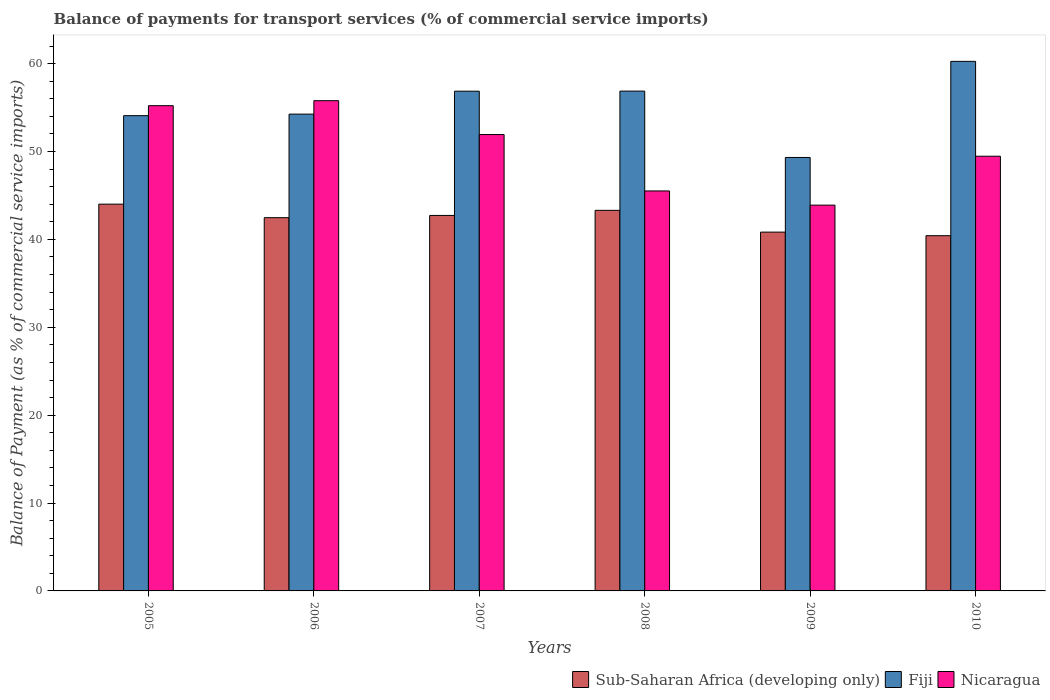Are the number of bars per tick equal to the number of legend labels?
Provide a succinct answer. Yes. Are the number of bars on each tick of the X-axis equal?
Ensure brevity in your answer.  Yes. How many bars are there on the 4th tick from the left?
Your answer should be compact. 3. What is the balance of payments for transport services in Nicaragua in 2009?
Keep it short and to the point. 43.9. Across all years, what is the maximum balance of payments for transport services in Nicaragua?
Offer a terse response. 55.78. Across all years, what is the minimum balance of payments for transport services in Sub-Saharan Africa (developing only)?
Your answer should be compact. 40.42. In which year was the balance of payments for transport services in Fiji maximum?
Offer a very short reply. 2010. What is the total balance of payments for transport services in Nicaragua in the graph?
Provide a short and direct response. 301.81. What is the difference between the balance of payments for transport services in Nicaragua in 2005 and that in 2009?
Provide a short and direct response. 11.32. What is the difference between the balance of payments for transport services in Nicaragua in 2007 and the balance of payments for transport services in Sub-Saharan Africa (developing only) in 2010?
Your answer should be very brief. 11.51. What is the average balance of payments for transport services in Nicaragua per year?
Your answer should be compact. 50.3. In the year 2008, what is the difference between the balance of payments for transport services in Nicaragua and balance of payments for transport services in Fiji?
Make the answer very short. -11.36. In how many years, is the balance of payments for transport services in Nicaragua greater than 32 %?
Give a very brief answer. 6. What is the ratio of the balance of payments for transport services in Sub-Saharan Africa (developing only) in 2007 to that in 2009?
Your response must be concise. 1.05. Is the difference between the balance of payments for transport services in Nicaragua in 2007 and 2008 greater than the difference between the balance of payments for transport services in Fiji in 2007 and 2008?
Give a very brief answer. Yes. What is the difference between the highest and the second highest balance of payments for transport services in Sub-Saharan Africa (developing only)?
Provide a short and direct response. 0.7. What is the difference between the highest and the lowest balance of payments for transport services in Fiji?
Give a very brief answer. 10.94. In how many years, is the balance of payments for transport services in Nicaragua greater than the average balance of payments for transport services in Nicaragua taken over all years?
Your answer should be compact. 3. What does the 1st bar from the left in 2005 represents?
Offer a very short reply. Sub-Saharan Africa (developing only). What does the 3rd bar from the right in 2009 represents?
Make the answer very short. Sub-Saharan Africa (developing only). Is it the case that in every year, the sum of the balance of payments for transport services in Sub-Saharan Africa (developing only) and balance of payments for transport services in Fiji is greater than the balance of payments for transport services in Nicaragua?
Provide a short and direct response. Yes. Are all the bars in the graph horizontal?
Your answer should be very brief. No. Are the values on the major ticks of Y-axis written in scientific E-notation?
Your answer should be compact. No. What is the title of the graph?
Give a very brief answer. Balance of payments for transport services (% of commercial service imports). Does "St. Vincent and the Grenadines" appear as one of the legend labels in the graph?
Your answer should be very brief. No. What is the label or title of the Y-axis?
Offer a very short reply. Balance of Payment (as % of commercial service imports). What is the Balance of Payment (as % of commercial service imports) in Sub-Saharan Africa (developing only) in 2005?
Provide a succinct answer. 44.01. What is the Balance of Payment (as % of commercial service imports) of Fiji in 2005?
Offer a very short reply. 54.08. What is the Balance of Payment (as % of commercial service imports) of Nicaragua in 2005?
Ensure brevity in your answer.  55.22. What is the Balance of Payment (as % of commercial service imports) of Sub-Saharan Africa (developing only) in 2006?
Make the answer very short. 42.47. What is the Balance of Payment (as % of commercial service imports) in Fiji in 2006?
Make the answer very short. 54.25. What is the Balance of Payment (as % of commercial service imports) in Nicaragua in 2006?
Your answer should be very brief. 55.78. What is the Balance of Payment (as % of commercial service imports) in Sub-Saharan Africa (developing only) in 2007?
Keep it short and to the point. 42.73. What is the Balance of Payment (as % of commercial service imports) in Fiji in 2007?
Make the answer very short. 56.86. What is the Balance of Payment (as % of commercial service imports) of Nicaragua in 2007?
Make the answer very short. 51.93. What is the Balance of Payment (as % of commercial service imports) of Sub-Saharan Africa (developing only) in 2008?
Ensure brevity in your answer.  43.31. What is the Balance of Payment (as % of commercial service imports) of Fiji in 2008?
Give a very brief answer. 56.87. What is the Balance of Payment (as % of commercial service imports) of Nicaragua in 2008?
Give a very brief answer. 45.51. What is the Balance of Payment (as % of commercial service imports) of Sub-Saharan Africa (developing only) in 2009?
Ensure brevity in your answer.  40.83. What is the Balance of Payment (as % of commercial service imports) of Fiji in 2009?
Give a very brief answer. 49.32. What is the Balance of Payment (as % of commercial service imports) of Nicaragua in 2009?
Provide a short and direct response. 43.9. What is the Balance of Payment (as % of commercial service imports) of Sub-Saharan Africa (developing only) in 2010?
Your answer should be very brief. 40.42. What is the Balance of Payment (as % of commercial service imports) in Fiji in 2010?
Provide a succinct answer. 60.26. What is the Balance of Payment (as % of commercial service imports) in Nicaragua in 2010?
Make the answer very short. 49.46. Across all years, what is the maximum Balance of Payment (as % of commercial service imports) in Sub-Saharan Africa (developing only)?
Offer a terse response. 44.01. Across all years, what is the maximum Balance of Payment (as % of commercial service imports) of Fiji?
Provide a succinct answer. 60.26. Across all years, what is the maximum Balance of Payment (as % of commercial service imports) of Nicaragua?
Ensure brevity in your answer.  55.78. Across all years, what is the minimum Balance of Payment (as % of commercial service imports) of Sub-Saharan Africa (developing only)?
Your response must be concise. 40.42. Across all years, what is the minimum Balance of Payment (as % of commercial service imports) in Fiji?
Your answer should be very brief. 49.32. Across all years, what is the minimum Balance of Payment (as % of commercial service imports) of Nicaragua?
Keep it short and to the point. 43.9. What is the total Balance of Payment (as % of commercial service imports) in Sub-Saharan Africa (developing only) in the graph?
Offer a terse response. 253.76. What is the total Balance of Payment (as % of commercial service imports) of Fiji in the graph?
Provide a short and direct response. 331.65. What is the total Balance of Payment (as % of commercial service imports) of Nicaragua in the graph?
Keep it short and to the point. 301.81. What is the difference between the Balance of Payment (as % of commercial service imports) in Sub-Saharan Africa (developing only) in 2005 and that in 2006?
Provide a succinct answer. 1.54. What is the difference between the Balance of Payment (as % of commercial service imports) in Fiji in 2005 and that in 2006?
Your answer should be very brief. -0.18. What is the difference between the Balance of Payment (as % of commercial service imports) of Nicaragua in 2005 and that in 2006?
Your answer should be compact. -0.57. What is the difference between the Balance of Payment (as % of commercial service imports) of Sub-Saharan Africa (developing only) in 2005 and that in 2007?
Offer a terse response. 1.28. What is the difference between the Balance of Payment (as % of commercial service imports) of Fiji in 2005 and that in 2007?
Provide a short and direct response. -2.78. What is the difference between the Balance of Payment (as % of commercial service imports) in Nicaragua in 2005 and that in 2007?
Offer a terse response. 3.29. What is the difference between the Balance of Payment (as % of commercial service imports) in Sub-Saharan Africa (developing only) in 2005 and that in 2008?
Provide a succinct answer. 0.7. What is the difference between the Balance of Payment (as % of commercial service imports) in Fiji in 2005 and that in 2008?
Provide a short and direct response. -2.8. What is the difference between the Balance of Payment (as % of commercial service imports) of Nicaragua in 2005 and that in 2008?
Make the answer very short. 9.7. What is the difference between the Balance of Payment (as % of commercial service imports) of Sub-Saharan Africa (developing only) in 2005 and that in 2009?
Keep it short and to the point. 3.18. What is the difference between the Balance of Payment (as % of commercial service imports) in Fiji in 2005 and that in 2009?
Make the answer very short. 4.76. What is the difference between the Balance of Payment (as % of commercial service imports) of Nicaragua in 2005 and that in 2009?
Your answer should be compact. 11.32. What is the difference between the Balance of Payment (as % of commercial service imports) in Sub-Saharan Africa (developing only) in 2005 and that in 2010?
Provide a succinct answer. 3.59. What is the difference between the Balance of Payment (as % of commercial service imports) in Fiji in 2005 and that in 2010?
Keep it short and to the point. -6.18. What is the difference between the Balance of Payment (as % of commercial service imports) in Nicaragua in 2005 and that in 2010?
Your answer should be compact. 5.75. What is the difference between the Balance of Payment (as % of commercial service imports) of Sub-Saharan Africa (developing only) in 2006 and that in 2007?
Offer a terse response. -0.26. What is the difference between the Balance of Payment (as % of commercial service imports) in Fiji in 2006 and that in 2007?
Your response must be concise. -2.61. What is the difference between the Balance of Payment (as % of commercial service imports) in Nicaragua in 2006 and that in 2007?
Make the answer very short. 3.85. What is the difference between the Balance of Payment (as % of commercial service imports) in Sub-Saharan Africa (developing only) in 2006 and that in 2008?
Make the answer very short. -0.84. What is the difference between the Balance of Payment (as % of commercial service imports) of Fiji in 2006 and that in 2008?
Keep it short and to the point. -2.62. What is the difference between the Balance of Payment (as % of commercial service imports) in Nicaragua in 2006 and that in 2008?
Provide a short and direct response. 10.27. What is the difference between the Balance of Payment (as % of commercial service imports) of Sub-Saharan Africa (developing only) in 2006 and that in 2009?
Your response must be concise. 1.64. What is the difference between the Balance of Payment (as % of commercial service imports) of Fiji in 2006 and that in 2009?
Your response must be concise. 4.93. What is the difference between the Balance of Payment (as % of commercial service imports) in Nicaragua in 2006 and that in 2009?
Keep it short and to the point. 11.89. What is the difference between the Balance of Payment (as % of commercial service imports) in Sub-Saharan Africa (developing only) in 2006 and that in 2010?
Provide a short and direct response. 2.05. What is the difference between the Balance of Payment (as % of commercial service imports) of Fiji in 2006 and that in 2010?
Your answer should be very brief. -6. What is the difference between the Balance of Payment (as % of commercial service imports) of Nicaragua in 2006 and that in 2010?
Give a very brief answer. 6.32. What is the difference between the Balance of Payment (as % of commercial service imports) of Sub-Saharan Africa (developing only) in 2007 and that in 2008?
Your answer should be compact. -0.58. What is the difference between the Balance of Payment (as % of commercial service imports) of Fiji in 2007 and that in 2008?
Keep it short and to the point. -0.01. What is the difference between the Balance of Payment (as % of commercial service imports) of Nicaragua in 2007 and that in 2008?
Give a very brief answer. 6.42. What is the difference between the Balance of Payment (as % of commercial service imports) in Sub-Saharan Africa (developing only) in 2007 and that in 2009?
Your response must be concise. 1.9. What is the difference between the Balance of Payment (as % of commercial service imports) in Fiji in 2007 and that in 2009?
Offer a terse response. 7.54. What is the difference between the Balance of Payment (as % of commercial service imports) of Nicaragua in 2007 and that in 2009?
Ensure brevity in your answer.  8.03. What is the difference between the Balance of Payment (as % of commercial service imports) in Sub-Saharan Africa (developing only) in 2007 and that in 2010?
Provide a short and direct response. 2.31. What is the difference between the Balance of Payment (as % of commercial service imports) of Fiji in 2007 and that in 2010?
Your answer should be very brief. -3.4. What is the difference between the Balance of Payment (as % of commercial service imports) in Nicaragua in 2007 and that in 2010?
Offer a terse response. 2.47. What is the difference between the Balance of Payment (as % of commercial service imports) in Sub-Saharan Africa (developing only) in 2008 and that in 2009?
Provide a succinct answer. 2.48. What is the difference between the Balance of Payment (as % of commercial service imports) in Fiji in 2008 and that in 2009?
Make the answer very short. 7.55. What is the difference between the Balance of Payment (as % of commercial service imports) of Nicaragua in 2008 and that in 2009?
Keep it short and to the point. 1.62. What is the difference between the Balance of Payment (as % of commercial service imports) in Sub-Saharan Africa (developing only) in 2008 and that in 2010?
Provide a succinct answer. 2.89. What is the difference between the Balance of Payment (as % of commercial service imports) in Fiji in 2008 and that in 2010?
Keep it short and to the point. -3.38. What is the difference between the Balance of Payment (as % of commercial service imports) in Nicaragua in 2008 and that in 2010?
Your answer should be very brief. -3.95. What is the difference between the Balance of Payment (as % of commercial service imports) in Sub-Saharan Africa (developing only) in 2009 and that in 2010?
Give a very brief answer. 0.41. What is the difference between the Balance of Payment (as % of commercial service imports) in Fiji in 2009 and that in 2010?
Ensure brevity in your answer.  -10.94. What is the difference between the Balance of Payment (as % of commercial service imports) in Nicaragua in 2009 and that in 2010?
Offer a terse response. -5.57. What is the difference between the Balance of Payment (as % of commercial service imports) in Sub-Saharan Africa (developing only) in 2005 and the Balance of Payment (as % of commercial service imports) in Fiji in 2006?
Offer a very short reply. -10.24. What is the difference between the Balance of Payment (as % of commercial service imports) of Sub-Saharan Africa (developing only) in 2005 and the Balance of Payment (as % of commercial service imports) of Nicaragua in 2006?
Your answer should be compact. -11.77. What is the difference between the Balance of Payment (as % of commercial service imports) in Fiji in 2005 and the Balance of Payment (as % of commercial service imports) in Nicaragua in 2006?
Make the answer very short. -1.71. What is the difference between the Balance of Payment (as % of commercial service imports) of Sub-Saharan Africa (developing only) in 2005 and the Balance of Payment (as % of commercial service imports) of Fiji in 2007?
Provide a short and direct response. -12.85. What is the difference between the Balance of Payment (as % of commercial service imports) of Sub-Saharan Africa (developing only) in 2005 and the Balance of Payment (as % of commercial service imports) of Nicaragua in 2007?
Your answer should be compact. -7.92. What is the difference between the Balance of Payment (as % of commercial service imports) of Fiji in 2005 and the Balance of Payment (as % of commercial service imports) of Nicaragua in 2007?
Offer a very short reply. 2.15. What is the difference between the Balance of Payment (as % of commercial service imports) in Sub-Saharan Africa (developing only) in 2005 and the Balance of Payment (as % of commercial service imports) in Fiji in 2008?
Make the answer very short. -12.86. What is the difference between the Balance of Payment (as % of commercial service imports) in Sub-Saharan Africa (developing only) in 2005 and the Balance of Payment (as % of commercial service imports) in Nicaragua in 2008?
Your answer should be very brief. -1.5. What is the difference between the Balance of Payment (as % of commercial service imports) in Fiji in 2005 and the Balance of Payment (as % of commercial service imports) in Nicaragua in 2008?
Offer a terse response. 8.57. What is the difference between the Balance of Payment (as % of commercial service imports) of Sub-Saharan Africa (developing only) in 2005 and the Balance of Payment (as % of commercial service imports) of Fiji in 2009?
Keep it short and to the point. -5.31. What is the difference between the Balance of Payment (as % of commercial service imports) in Sub-Saharan Africa (developing only) in 2005 and the Balance of Payment (as % of commercial service imports) in Nicaragua in 2009?
Provide a short and direct response. 0.11. What is the difference between the Balance of Payment (as % of commercial service imports) in Fiji in 2005 and the Balance of Payment (as % of commercial service imports) in Nicaragua in 2009?
Provide a short and direct response. 10.18. What is the difference between the Balance of Payment (as % of commercial service imports) in Sub-Saharan Africa (developing only) in 2005 and the Balance of Payment (as % of commercial service imports) in Fiji in 2010?
Your answer should be compact. -16.25. What is the difference between the Balance of Payment (as % of commercial service imports) of Sub-Saharan Africa (developing only) in 2005 and the Balance of Payment (as % of commercial service imports) of Nicaragua in 2010?
Offer a terse response. -5.45. What is the difference between the Balance of Payment (as % of commercial service imports) of Fiji in 2005 and the Balance of Payment (as % of commercial service imports) of Nicaragua in 2010?
Keep it short and to the point. 4.62. What is the difference between the Balance of Payment (as % of commercial service imports) of Sub-Saharan Africa (developing only) in 2006 and the Balance of Payment (as % of commercial service imports) of Fiji in 2007?
Make the answer very short. -14.39. What is the difference between the Balance of Payment (as % of commercial service imports) of Sub-Saharan Africa (developing only) in 2006 and the Balance of Payment (as % of commercial service imports) of Nicaragua in 2007?
Your response must be concise. -9.46. What is the difference between the Balance of Payment (as % of commercial service imports) in Fiji in 2006 and the Balance of Payment (as % of commercial service imports) in Nicaragua in 2007?
Offer a very short reply. 2.32. What is the difference between the Balance of Payment (as % of commercial service imports) in Sub-Saharan Africa (developing only) in 2006 and the Balance of Payment (as % of commercial service imports) in Fiji in 2008?
Your answer should be very brief. -14.4. What is the difference between the Balance of Payment (as % of commercial service imports) in Sub-Saharan Africa (developing only) in 2006 and the Balance of Payment (as % of commercial service imports) in Nicaragua in 2008?
Your answer should be very brief. -3.04. What is the difference between the Balance of Payment (as % of commercial service imports) in Fiji in 2006 and the Balance of Payment (as % of commercial service imports) in Nicaragua in 2008?
Give a very brief answer. 8.74. What is the difference between the Balance of Payment (as % of commercial service imports) in Sub-Saharan Africa (developing only) in 2006 and the Balance of Payment (as % of commercial service imports) in Fiji in 2009?
Your answer should be very brief. -6.85. What is the difference between the Balance of Payment (as % of commercial service imports) in Sub-Saharan Africa (developing only) in 2006 and the Balance of Payment (as % of commercial service imports) in Nicaragua in 2009?
Your response must be concise. -1.43. What is the difference between the Balance of Payment (as % of commercial service imports) of Fiji in 2006 and the Balance of Payment (as % of commercial service imports) of Nicaragua in 2009?
Ensure brevity in your answer.  10.36. What is the difference between the Balance of Payment (as % of commercial service imports) of Sub-Saharan Africa (developing only) in 2006 and the Balance of Payment (as % of commercial service imports) of Fiji in 2010?
Keep it short and to the point. -17.79. What is the difference between the Balance of Payment (as % of commercial service imports) of Sub-Saharan Africa (developing only) in 2006 and the Balance of Payment (as % of commercial service imports) of Nicaragua in 2010?
Offer a very short reply. -6.99. What is the difference between the Balance of Payment (as % of commercial service imports) in Fiji in 2006 and the Balance of Payment (as % of commercial service imports) in Nicaragua in 2010?
Make the answer very short. 4.79. What is the difference between the Balance of Payment (as % of commercial service imports) in Sub-Saharan Africa (developing only) in 2007 and the Balance of Payment (as % of commercial service imports) in Fiji in 2008?
Offer a terse response. -14.15. What is the difference between the Balance of Payment (as % of commercial service imports) in Sub-Saharan Africa (developing only) in 2007 and the Balance of Payment (as % of commercial service imports) in Nicaragua in 2008?
Make the answer very short. -2.79. What is the difference between the Balance of Payment (as % of commercial service imports) in Fiji in 2007 and the Balance of Payment (as % of commercial service imports) in Nicaragua in 2008?
Offer a very short reply. 11.35. What is the difference between the Balance of Payment (as % of commercial service imports) of Sub-Saharan Africa (developing only) in 2007 and the Balance of Payment (as % of commercial service imports) of Fiji in 2009?
Your response must be concise. -6.6. What is the difference between the Balance of Payment (as % of commercial service imports) in Sub-Saharan Africa (developing only) in 2007 and the Balance of Payment (as % of commercial service imports) in Nicaragua in 2009?
Offer a terse response. -1.17. What is the difference between the Balance of Payment (as % of commercial service imports) of Fiji in 2007 and the Balance of Payment (as % of commercial service imports) of Nicaragua in 2009?
Provide a succinct answer. 12.96. What is the difference between the Balance of Payment (as % of commercial service imports) in Sub-Saharan Africa (developing only) in 2007 and the Balance of Payment (as % of commercial service imports) in Fiji in 2010?
Keep it short and to the point. -17.53. What is the difference between the Balance of Payment (as % of commercial service imports) of Sub-Saharan Africa (developing only) in 2007 and the Balance of Payment (as % of commercial service imports) of Nicaragua in 2010?
Your response must be concise. -6.74. What is the difference between the Balance of Payment (as % of commercial service imports) in Fiji in 2007 and the Balance of Payment (as % of commercial service imports) in Nicaragua in 2010?
Make the answer very short. 7.4. What is the difference between the Balance of Payment (as % of commercial service imports) in Sub-Saharan Africa (developing only) in 2008 and the Balance of Payment (as % of commercial service imports) in Fiji in 2009?
Provide a short and direct response. -6.02. What is the difference between the Balance of Payment (as % of commercial service imports) of Sub-Saharan Africa (developing only) in 2008 and the Balance of Payment (as % of commercial service imports) of Nicaragua in 2009?
Provide a short and direct response. -0.59. What is the difference between the Balance of Payment (as % of commercial service imports) in Fiji in 2008 and the Balance of Payment (as % of commercial service imports) in Nicaragua in 2009?
Keep it short and to the point. 12.98. What is the difference between the Balance of Payment (as % of commercial service imports) of Sub-Saharan Africa (developing only) in 2008 and the Balance of Payment (as % of commercial service imports) of Fiji in 2010?
Keep it short and to the point. -16.95. What is the difference between the Balance of Payment (as % of commercial service imports) of Sub-Saharan Africa (developing only) in 2008 and the Balance of Payment (as % of commercial service imports) of Nicaragua in 2010?
Provide a succinct answer. -6.16. What is the difference between the Balance of Payment (as % of commercial service imports) of Fiji in 2008 and the Balance of Payment (as % of commercial service imports) of Nicaragua in 2010?
Your response must be concise. 7.41. What is the difference between the Balance of Payment (as % of commercial service imports) in Sub-Saharan Africa (developing only) in 2009 and the Balance of Payment (as % of commercial service imports) in Fiji in 2010?
Keep it short and to the point. -19.43. What is the difference between the Balance of Payment (as % of commercial service imports) of Sub-Saharan Africa (developing only) in 2009 and the Balance of Payment (as % of commercial service imports) of Nicaragua in 2010?
Your response must be concise. -8.64. What is the difference between the Balance of Payment (as % of commercial service imports) of Fiji in 2009 and the Balance of Payment (as % of commercial service imports) of Nicaragua in 2010?
Provide a succinct answer. -0.14. What is the average Balance of Payment (as % of commercial service imports) in Sub-Saharan Africa (developing only) per year?
Your answer should be very brief. 42.29. What is the average Balance of Payment (as % of commercial service imports) in Fiji per year?
Your answer should be very brief. 55.28. What is the average Balance of Payment (as % of commercial service imports) of Nicaragua per year?
Ensure brevity in your answer.  50.3. In the year 2005, what is the difference between the Balance of Payment (as % of commercial service imports) in Sub-Saharan Africa (developing only) and Balance of Payment (as % of commercial service imports) in Fiji?
Ensure brevity in your answer.  -10.07. In the year 2005, what is the difference between the Balance of Payment (as % of commercial service imports) of Sub-Saharan Africa (developing only) and Balance of Payment (as % of commercial service imports) of Nicaragua?
Keep it short and to the point. -11.21. In the year 2005, what is the difference between the Balance of Payment (as % of commercial service imports) of Fiji and Balance of Payment (as % of commercial service imports) of Nicaragua?
Your response must be concise. -1.14. In the year 2006, what is the difference between the Balance of Payment (as % of commercial service imports) in Sub-Saharan Africa (developing only) and Balance of Payment (as % of commercial service imports) in Fiji?
Offer a terse response. -11.78. In the year 2006, what is the difference between the Balance of Payment (as % of commercial service imports) of Sub-Saharan Africa (developing only) and Balance of Payment (as % of commercial service imports) of Nicaragua?
Provide a succinct answer. -13.31. In the year 2006, what is the difference between the Balance of Payment (as % of commercial service imports) in Fiji and Balance of Payment (as % of commercial service imports) in Nicaragua?
Offer a very short reply. -1.53. In the year 2007, what is the difference between the Balance of Payment (as % of commercial service imports) of Sub-Saharan Africa (developing only) and Balance of Payment (as % of commercial service imports) of Fiji?
Your response must be concise. -14.14. In the year 2007, what is the difference between the Balance of Payment (as % of commercial service imports) in Sub-Saharan Africa (developing only) and Balance of Payment (as % of commercial service imports) in Nicaragua?
Your response must be concise. -9.21. In the year 2007, what is the difference between the Balance of Payment (as % of commercial service imports) in Fiji and Balance of Payment (as % of commercial service imports) in Nicaragua?
Offer a very short reply. 4.93. In the year 2008, what is the difference between the Balance of Payment (as % of commercial service imports) of Sub-Saharan Africa (developing only) and Balance of Payment (as % of commercial service imports) of Fiji?
Ensure brevity in your answer.  -13.57. In the year 2008, what is the difference between the Balance of Payment (as % of commercial service imports) of Sub-Saharan Africa (developing only) and Balance of Payment (as % of commercial service imports) of Nicaragua?
Your response must be concise. -2.21. In the year 2008, what is the difference between the Balance of Payment (as % of commercial service imports) of Fiji and Balance of Payment (as % of commercial service imports) of Nicaragua?
Your response must be concise. 11.36. In the year 2009, what is the difference between the Balance of Payment (as % of commercial service imports) in Sub-Saharan Africa (developing only) and Balance of Payment (as % of commercial service imports) in Fiji?
Give a very brief answer. -8.5. In the year 2009, what is the difference between the Balance of Payment (as % of commercial service imports) of Sub-Saharan Africa (developing only) and Balance of Payment (as % of commercial service imports) of Nicaragua?
Provide a succinct answer. -3.07. In the year 2009, what is the difference between the Balance of Payment (as % of commercial service imports) in Fiji and Balance of Payment (as % of commercial service imports) in Nicaragua?
Keep it short and to the point. 5.42. In the year 2010, what is the difference between the Balance of Payment (as % of commercial service imports) of Sub-Saharan Africa (developing only) and Balance of Payment (as % of commercial service imports) of Fiji?
Your answer should be compact. -19.84. In the year 2010, what is the difference between the Balance of Payment (as % of commercial service imports) in Sub-Saharan Africa (developing only) and Balance of Payment (as % of commercial service imports) in Nicaragua?
Your answer should be very brief. -9.04. In the year 2010, what is the difference between the Balance of Payment (as % of commercial service imports) of Fiji and Balance of Payment (as % of commercial service imports) of Nicaragua?
Provide a short and direct response. 10.8. What is the ratio of the Balance of Payment (as % of commercial service imports) in Sub-Saharan Africa (developing only) in 2005 to that in 2006?
Make the answer very short. 1.04. What is the ratio of the Balance of Payment (as % of commercial service imports) in Nicaragua in 2005 to that in 2006?
Make the answer very short. 0.99. What is the ratio of the Balance of Payment (as % of commercial service imports) in Sub-Saharan Africa (developing only) in 2005 to that in 2007?
Provide a succinct answer. 1.03. What is the ratio of the Balance of Payment (as % of commercial service imports) in Fiji in 2005 to that in 2007?
Provide a succinct answer. 0.95. What is the ratio of the Balance of Payment (as % of commercial service imports) in Nicaragua in 2005 to that in 2007?
Give a very brief answer. 1.06. What is the ratio of the Balance of Payment (as % of commercial service imports) in Sub-Saharan Africa (developing only) in 2005 to that in 2008?
Your response must be concise. 1.02. What is the ratio of the Balance of Payment (as % of commercial service imports) of Fiji in 2005 to that in 2008?
Make the answer very short. 0.95. What is the ratio of the Balance of Payment (as % of commercial service imports) of Nicaragua in 2005 to that in 2008?
Your answer should be very brief. 1.21. What is the ratio of the Balance of Payment (as % of commercial service imports) in Sub-Saharan Africa (developing only) in 2005 to that in 2009?
Provide a succinct answer. 1.08. What is the ratio of the Balance of Payment (as % of commercial service imports) of Fiji in 2005 to that in 2009?
Make the answer very short. 1.1. What is the ratio of the Balance of Payment (as % of commercial service imports) of Nicaragua in 2005 to that in 2009?
Give a very brief answer. 1.26. What is the ratio of the Balance of Payment (as % of commercial service imports) of Sub-Saharan Africa (developing only) in 2005 to that in 2010?
Your answer should be very brief. 1.09. What is the ratio of the Balance of Payment (as % of commercial service imports) of Fiji in 2005 to that in 2010?
Your response must be concise. 0.9. What is the ratio of the Balance of Payment (as % of commercial service imports) in Nicaragua in 2005 to that in 2010?
Offer a terse response. 1.12. What is the ratio of the Balance of Payment (as % of commercial service imports) in Fiji in 2006 to that in 2007?
Keep it short and to the point. 0.95. What is the ratio of the Balance of Payment (as % of commercial service imports) in Nicaragua in 2006 to that in 2007?
Your answer should be compact. 1.07. What is the ratio of the Balance of Payment (as % of commercial service imports) of Sub-Saharan Africa (developing only) in 2006 to that in 2008?
Your answer should be very brief. 0.98. What is the ratio of the Balance of Payment (as % of commercial service imports) in Fiji in 2006 to that in 2008?
Your answer should be very brief. 0.95. What is the ratio of the Balance of Payment (as % of commercial service imports) in Nicaragua in 2006 to that in 2008?
Give a very brief answer. 1.23. What is the ratio of the Balance of Payment (as % of commercial service imports) of Sub-Saharan Africa (developing only) in 2006 to that in 2009?
Give a very brief answer. 1.04. What is the ratio of the Balance of Payment (as % of commercial service imports) in Fiji in 2006 to that in 2009?
Your response must be concise. 1.1. What is the ratio of the Balance of Payment (as % of commercial service imports) of Nicaragua in 2006 to that in 2009?
Offer a terse response. 1.27. What is the ratio of the Balance of Payment (as % of commercial service imports) in Sub-Saharan Africa (developing only) in 2006 to that in 2010?
Ensure brevity in your answer.  1.05. What is the ratio of the Balance of Payment (as % of commercial service imports) of Fiji in 2006 to that in 2010?
Provide a succinct answer. 0.9. What is the ratio of the Balance of Payment (as % of commercial service imports) in Nicaragua in 2006 to that in 2010?
Ensure brevity in your answer.  1.13. What is the ratio of the Balance of Payment (as % of commercial service imports) in Sub-Saharan Africa (developing only) in 2007 to that in 2008?
Give a very brief answer. 0.99. What is the ratio of the Balance of Payment (as % of commercial service imports) of Fiji in 2007 to that in 2008?
Give a very brief answer. 1. What is the ratio of the Balance of Payment (as % of commercial service imports) of Nicaragua in 2007 to that in 2008?
Offer a very short reply. 1.14. What is the ratio of the Balance of Payment (as % of commercial service imports) in Sub-Saharan Africa (developing only) in 2007 to that in 2009?
Your answer should be compact. 1.05. What is the ratio of the Balance of Payment (as % of commercial service imports) of Fiji in 2007 to that in 2009?
Give a very brief answer. 1.15. What is the ratio of the Balance of Payment (as % of commercial service imports) in Nicaragua in 2007 to that in 2009?
Ensure brevity in your answer.  1.18. What is the ratio of the Balance of Payment (as % of commercial service imports) in Sub-Saharan Africa (developing only) in 2007 to that in 2010?
Your answer should be compact. 1.06. What is the ratio of the Balance of Payment (as % of commercial service imports) of Fiji in 2007 to that in 2010?
Offer a terse response. 0.94. What is the ratio of the Balance of Payment (as % of commercial service imports) of Nicaragua in 2007 to that in 2010?
Ensure brevity in your answer.  1.05. What is the ratio of the Balance of Payment (as % of commercial service imports) in Sub-Saharan Africa (developing only) in 2008 to that in 2009?
Keep it short and to the point. 1.06. What is the ratio of the Balance of Payment (as % of commercial service imports) in Fiji in 2008 to that in 2009?
Your answer should be compact. 1.15. What is the ratio of the Balance of Payment (as % of commercial service imports) in Nicaragua in 2008 to that in 2009?
Give a very brief answer. 1.04. What is the ratio of the Balance of Payment (as % of commercial service imports) of Sub-Saharan Africa (developing only) in 2008 to that in 2010?
Give a very brief answer. 1.07. What is the ratio of the Balance of Payment (as % of commercial service imports) of Fiji in 2008 to that in 2010?
Ensure brevity in your answer.  0.94. What is the ratio of the Balance of Payment (as % of commercial service imports) in Nicaragua in 2008 to that in 2010?
Ensure brevity in your answer.  0.92. What is the ratio of the Balance of Payment (as % of commercial service imports) in Sub-Saharan Africa (developing only) in 2009 to that in 2010?
Your answer should be very brief. 1.01. What is the ratio of the Balance of Payment (as % of commercial service imports) in Fiji in 2009 to that in 2010?
Your answer should be compact. 0.82. What is the ratio of the Balance of Payment (as % of commercial service imports) in Nicaragua in 2009 to that in 2010?
Ensure brevity in your answer.  0.89. What is the difference between the highest and the second highest Balance of Payment (as % of commercial service imports) in Sub-Saharan Africa (developing only)?
Offer a terse response. 0.7. What is the difference between the highest and the second highest Balance of Payment (as % of commercial service imports) of Fiji?
Keep it short and to the point. 3.38. What is the difference between the highest and the second highest Balance of Payment (as % of commercial service imports) in Nicaragua?
Your answer should be very brief. 0.57. What is the difference between the highest and the lowest Balance of Payment (as % of commercial service imports) of Sub-Saharan Africa (developing only)?
Give a very brief answer. 3.59. What is the difference between the highest and the lowest Balance of Payment (as % of commercial service imports) of Fiji?
Your answer should be compact. 10.94. What is the difference between the highest and the lowest Balance of Payment (as % of commercial service imports) in Nicaragua?
Keep it short and to the point. 11.89. 